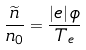Convert formula to latex. <formula><loc_0><loc_0><loc_500><loc_500>\frac { \widetilde { n } } { n _ { 0 } } = \frac { \left | e \right | \phi } { T _ { e } }</formula> 